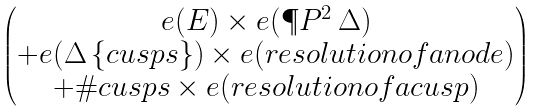<formula> <loc_0><loc_0><loc_500><loc_500>\begin{pmatrix} e ( E ) \times e ( \P P ^ { 2 } \ \Delta ) \\ + e ( \Delta \ \{ c u s p s \} ) \times e ( r e s o l u t i o n o f a n o d e ) \\ + \# c u s p s \times e ( r e s o l u t i o n o f a c u s p ) \end{pmatrix}</formula> 